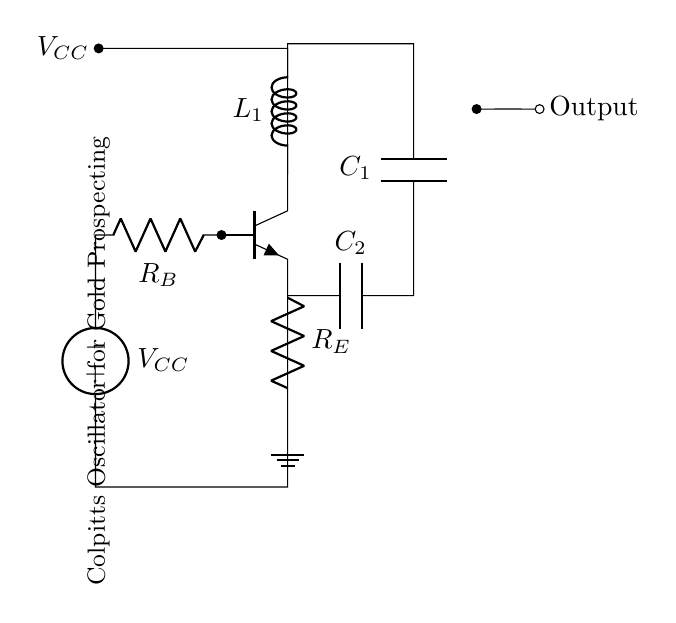What is the type of oscillator shown in the diagram? The circuit is a Colpitts oscillator, which is identified by the arrangement of capacitors and inductors used to generate oscillations.
Answer: Colpitts oscillator What components are used for frequency determination? The capacitors C1 and C2, along with the inductor L1, are part of the feedback network that determines the oscillator's frequency of oscillation.
Answer: C1, C2, L1 What is the function of the resistor R_E? R_E is used for emitter stabilization and biasing the transistor to ensure proper operation of the oscillator circuit, reducing distortion.
Answer: Emitter stabilization Which voltage source powers the circuit? The circuit is powered by the voltage source labeled V_CC, which provides the necessary supply voltage for the transistor operation.
Answer: V_CC If the capacitors C1 and C2 have equal values, what does that indicate about the oscillation frequency? When C1 and C2 are equal, the formula for the frequency of oscillation suggests that the frequency will be primarily determined by the values of L1 and the capacitors; thus, equal capacitance can lead to a predictable frequency.
Answer: Predictable frequency How is the output signal obtained from this oscillator? The output signal is taken from the collector of the transistor, where it is connected to a load or further circuitry, indicated by the output node on the diagram.
Answer: Collector of the transistor What is the primary purpose of this oscillator in gold prospecting? This oscillator generates stable frequencies that can be used in metal detectors to identify metallic objects such as gold by detecting their electromagnetic signatures.
Answer: Metal detection 